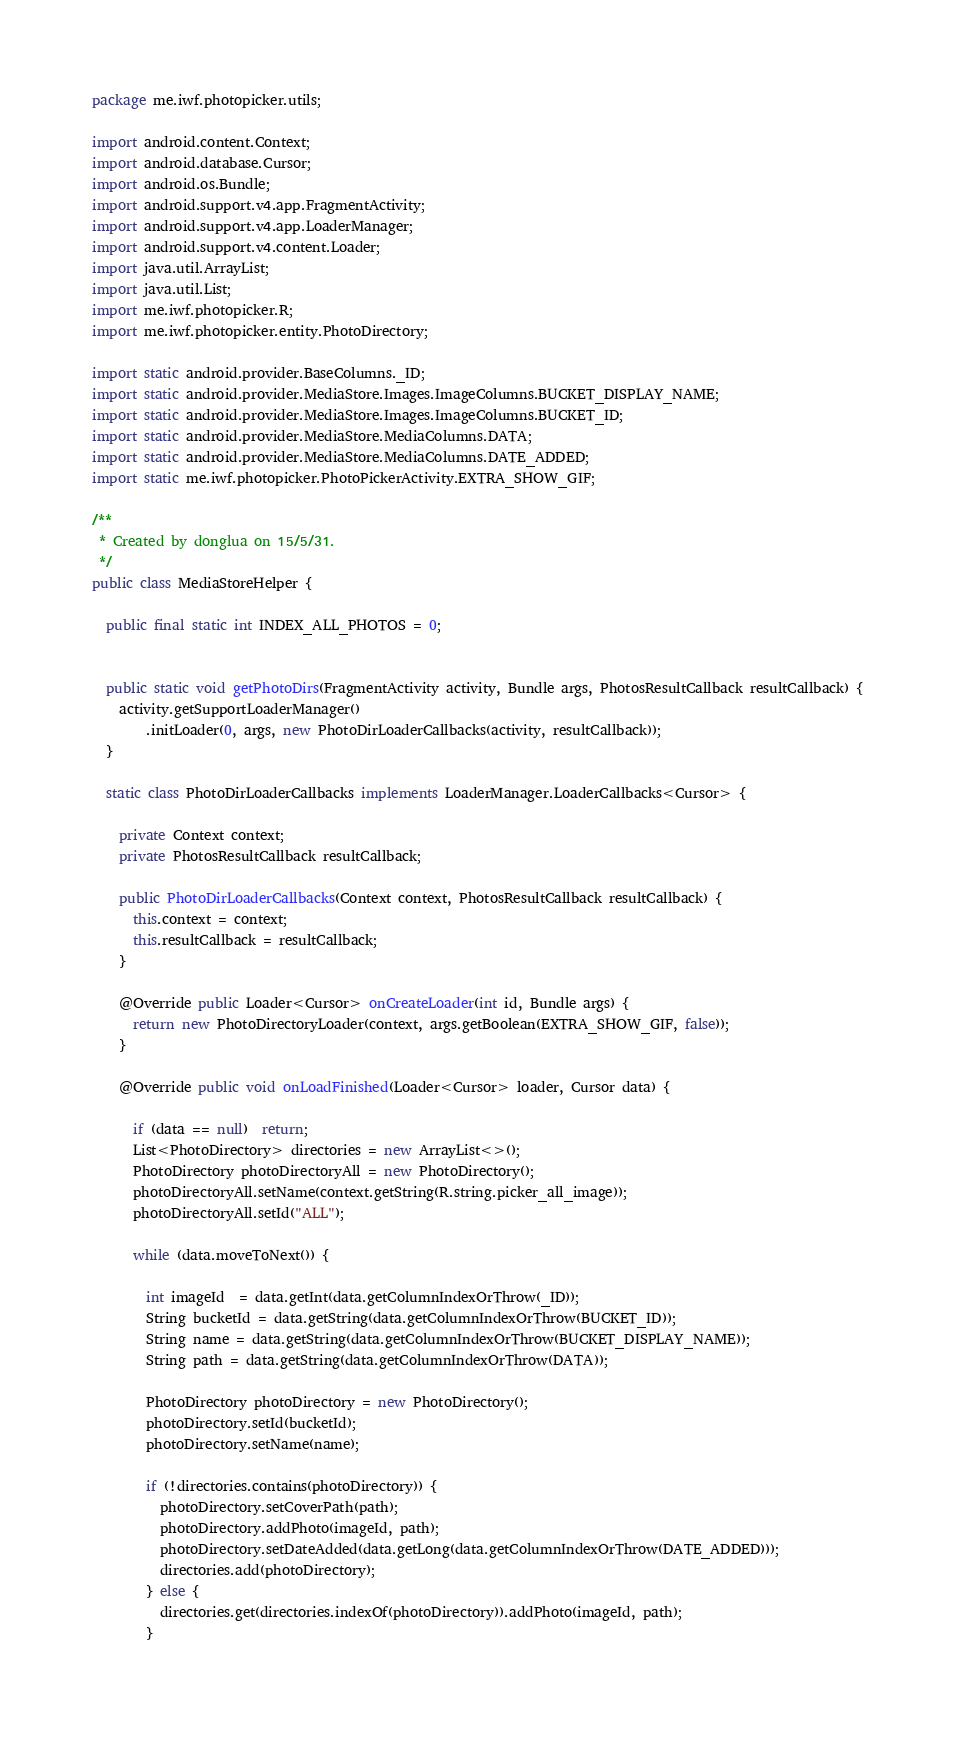Convert code to text. <code><loc_0><loc_0><loc_500><loc_500><_Java_>package me.iwf.photopicker.utils;

import android.content.Context;
import android.database.Cursor;
import android.os.Bundle;
import android.support.v4.app.FragmentActivity;
import android.support.v4.app.LoaderManager;
import android.support.v4.content.Loader;
import java.util.ArrayList;
import java.util.List;
import me.iwf.photopicker.R;
import me.iwf.photopicker.entity.PhotoDirectory;

import static android.provider.BaseColumns._ID;
import static android.provider.MediaStore.Images.ImageColumns.BUCKET_DISPLAY_NAME;
import static android.provider.MediaStore.Images.ImageColumns.BUCKET_ID;
import static android.provider.MediaStore.MediaColumns.DATA;
import static android.provider.MediaStore.MediaColumns.DATE_ADDED;
import static me.iwf.photopicker.PhotoPickerActivity.EXTRA_SHOW_GIF;

/**
 * Created by donglua on 15/5/31.
 */
public class MediaStoreHelper {

  public final static int INDEX_ALL_PHOTOS = 0;


  public static void getPhotoDirs(FragmentActivity activity, Bundle args, PhotosResultCallback resultCallback) {
    activity.getSupportLoaderManager()
        .initLoader(0, args, new PhotoDirLoaderCallbacks(activity, resultCallback));
  }

  static class PhotoDirLoaderCallbacks implements LoaderManager.LoaderCallbacks<Cursor> {

    private Context context;
    private PhotosResultCallback resultCallback;

    public PhotoDirLoaderCallbacks(Context context, PhotosResultCallback resultCallback) {
      this.context = context;
      this.resultCallback = resultCallback;
    }

    @Override public Loader<Cursor> onCreateLoader(int id, Bundle args) {
      return new PhotoDirectoryLoader(context, args.getBoolean(EXTRA_SHOW_GIF, false));
    }

    @Override public void onLoadFinished(Loader<Cursor> loader, Cursor data) {

      if (data == null)  return;
      List<PhotoDirectory> directories = new ArrayList<>();
      PhotoDirectory photoDirectoryAll = new PhotoDirectory();
      photoDirectoryAll.setName(context.getString(R.string.picker_all_image));
      photoDirectoryAll.setId("ALL");

      while (data.moveToNext()) {

        int imageId  = data.getInt(data.getColumnIndexOrThrow(_ID));
        String bucketId = data.getString(data.getColumnIndexOrThrow(BUCKET_ID));
        String name = data.getString(data.getColumnIndexOrThrow(BUCKET_DISPLAY_NAME));
        String path = data.getString(data.getColumnIndexOrThrow(DATA));

        PhotoDirectory photoDirectory = new PhotoDirectory();
        photoDirectory.setId(bucketId);
        photoDirectory.setName(name);

        if (!directories.contains(photoDirectory)) {
          photoDirectory.setCoverPath(path);
          photoDirectory.addPhoto(imageId, path);
          photoDirectory.setDateAdded(data.getLong(data.getColumnIndexOrThrow(DATE_ADDED)));
          directories.add(photoDirectory);
        } else {
          directories.get(directories.indexOf(photoDirectory)).addPhoto(imageId, path);
        }
</code> 